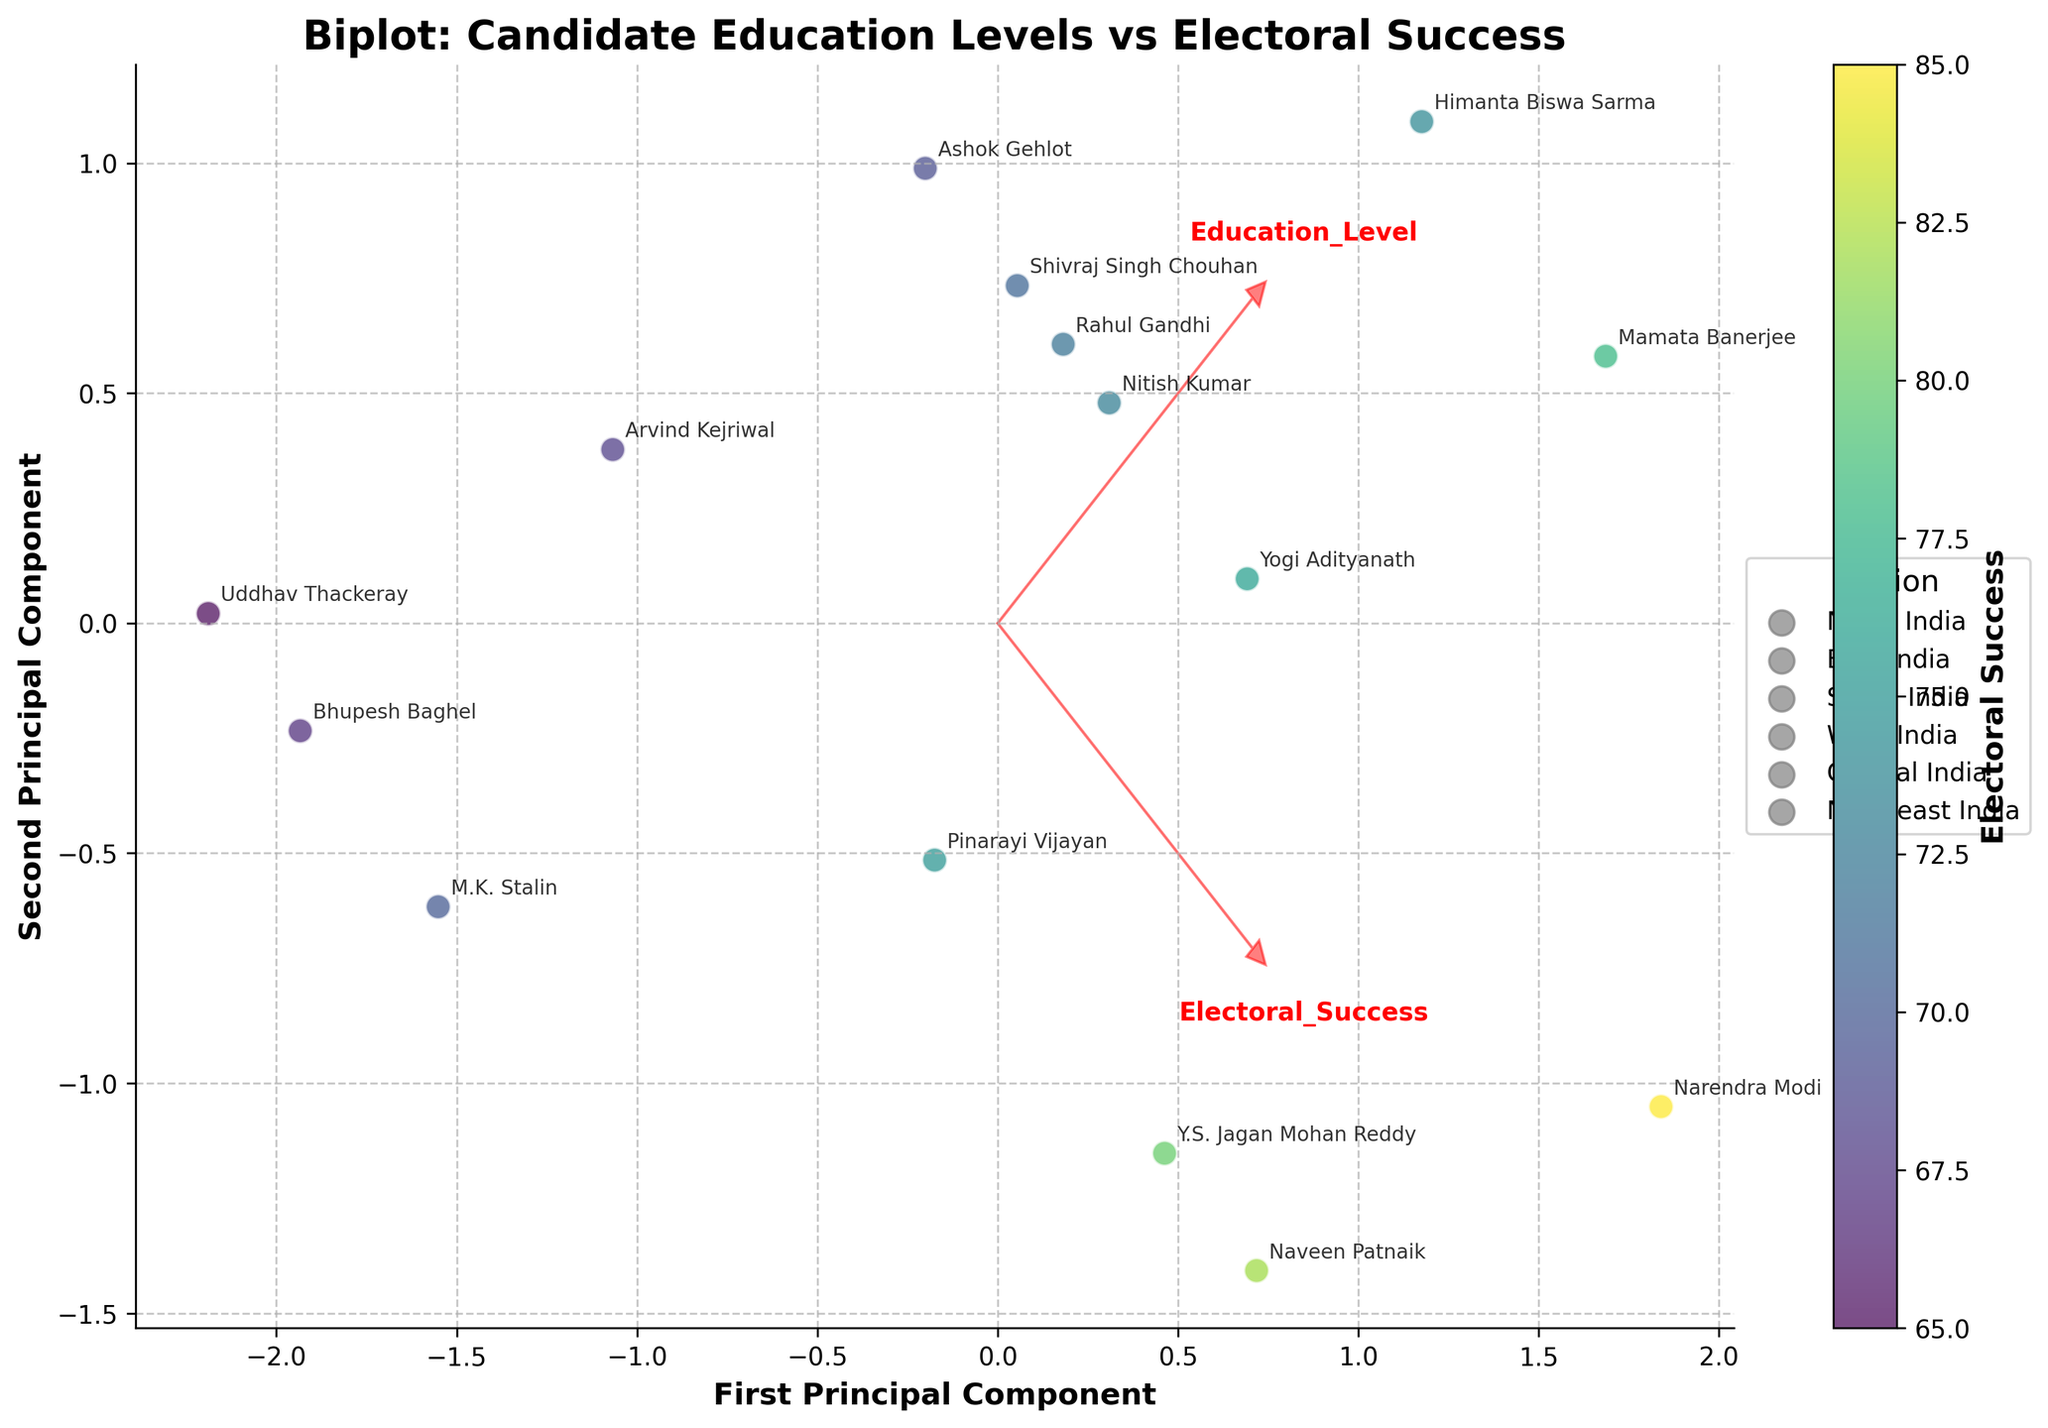Which candidate has the highest electoral success in the plot? By observing the labels on the data points and cross-referencing their positions with the color bar indicating electoral success, note that Narendra Modi is labeled and colored accordingly to have the highest electoral success.
Answer: Narendra Modi Which region has the most candidates on the plot? By looking at the labeled data points and their corresponding regions, North India appears most frequently. This can be seen in the clustering of points labeled as candidates from North India.
Answer: North India What does the first principal component represent on the biplot? The first principal component, labeled on the x-axis, is a linear combination of Education Level and Electoral Success. Its direction and length are derived from the significant contribution of these variables.
Answer: A combination of Education Level and Electoral Success How many candidates have a Post-Graduate education level according to the plot? By identifying data points labeled with Post-Graduate education and checking the region they represent, there are five such candidates labeled around the biplot.
Answer: Five Which region shows the highest concentration of candidates with high electoral success? By examining the color intensities mapped to data points and correlating them with regions, North India has the highest concentration since most points from this region are in darker colors indicating higher success.
Answer: North India Are there any candidates from the Northeast region? By checking the legend and observing the data points labeled with the Northeast region, only one candidate, Himanta Biswa Sarma, is plotted.
Answer: Yes Is there a discernible pattern between education level and electoral success across different regions? By observing the position of points and their respective colors, candidates with higher education (Post-Graduate and PhD) generally cluster towards higher electoral success, irrespective of the region.
Answer: Yes Are candidates with a PhD uniformly distributed across regions? Analyzing the labels around data points for PhD candidates, they appear in both East and Northeast India, indicating they are not confined to a single region.
Answer: No Which principal component has a stronger relationship with the candidates' education levels? By observing the direction and length of the arrows representing Education Level, the first principal component (x-axis) has closer alignment, indicating a stronger relationship.
Answer: First principal component What does the arrow originating from the origin represent in the context of a biplot? The arrow in a biplot represents the contribution of a particular variable, where the direction shows the variable's effect on the principal components and the length indicates its magnitude.
Answer: Contribution of variables 